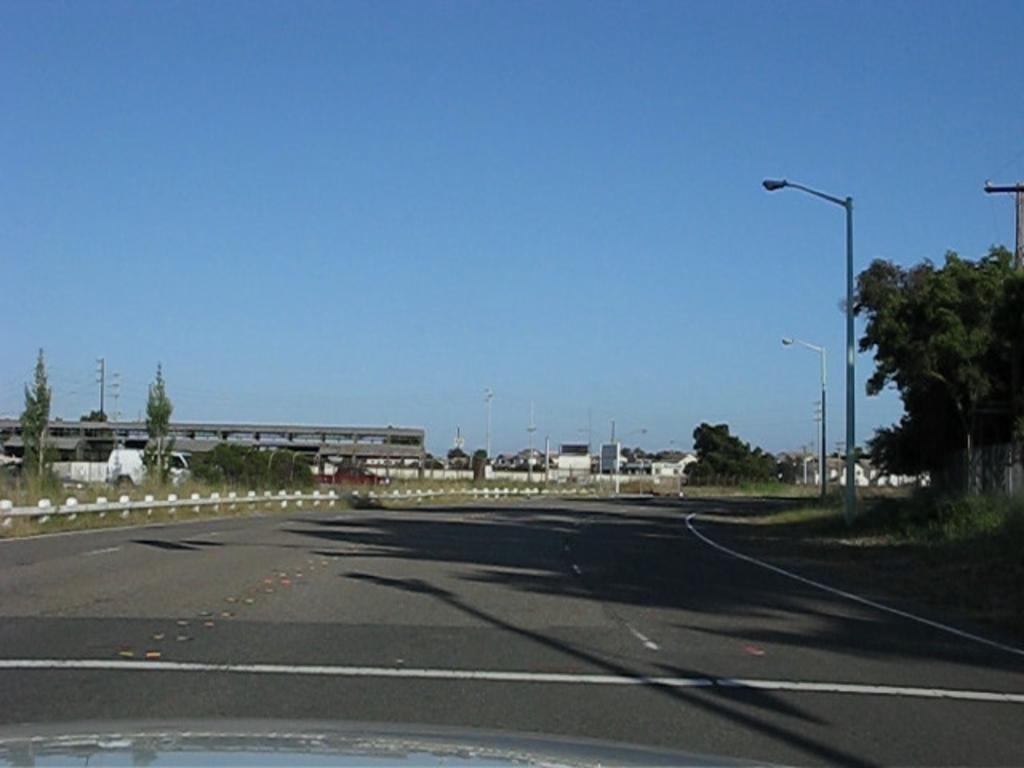How would you summarize this image in a sentence or two? In this image, we can see trees, plants, poles, lights, houses, vehicle, road. Background there is a clear sky. 